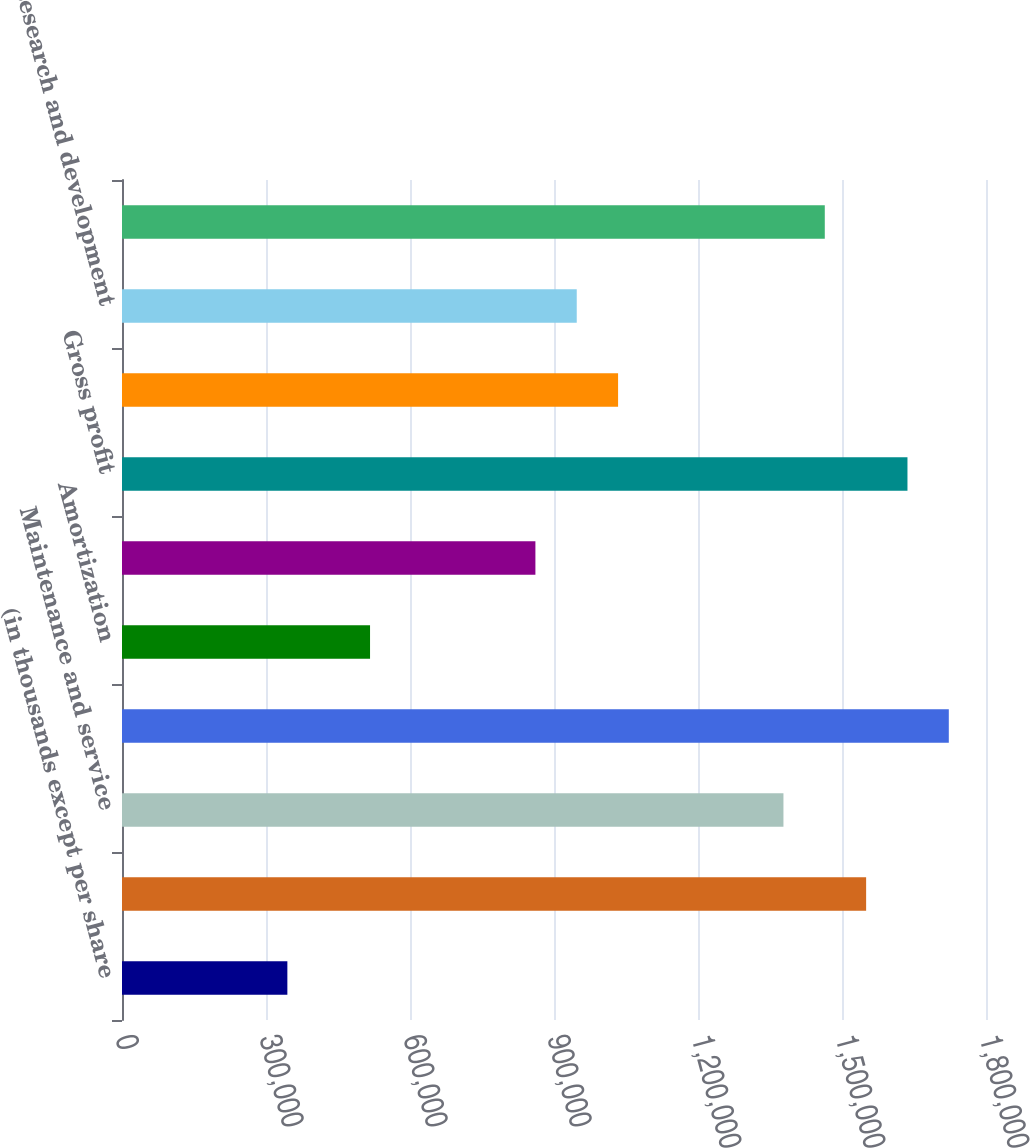Convert chart to OTSL. <chart><loc_0><loc_0><loc_500><loc_500><bar_chart><fcel>(in thousands except per share<fcel>Software licenses<fcel>Maintenance and service<fcel>Total revenue<fcel>Amortization<fcel>Total cost of sales<fcel>Gross profit<fcel>Selling general and<fcel>Research and development<fcel>Total operating expenses<nl><fcel>344506<fcel>1.55027e+06<fcel>1.37801e+06<fcel>1.72252e+06<fcel>516757<fcel>861260<fcel>1.63639e+06<fcel>1.03351e+06<fcel>947386<fcel>1.46414e+06<nl></chart> 